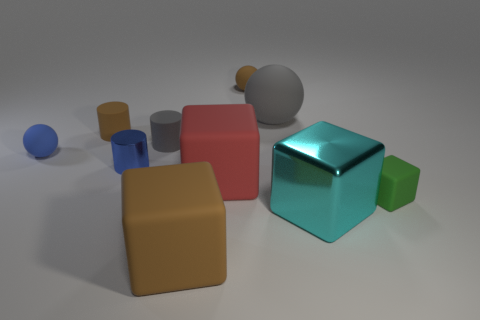Subtract 1 cubes. How many cubes are left? 3 Subtract all spheres. How many objects are left? 7 Add 6 tiny matte cylinders. How many tiny matte cylinders are left? 8 Add 8 tiny brown matte cylinders. How many tiny brown matte cylinders exist? 9 Subtract 0 purple cylinders. How many objects are left? 10 Subtract all big green metal spheres. Subtract all tiny matte spheres. How many objects are left? 8 